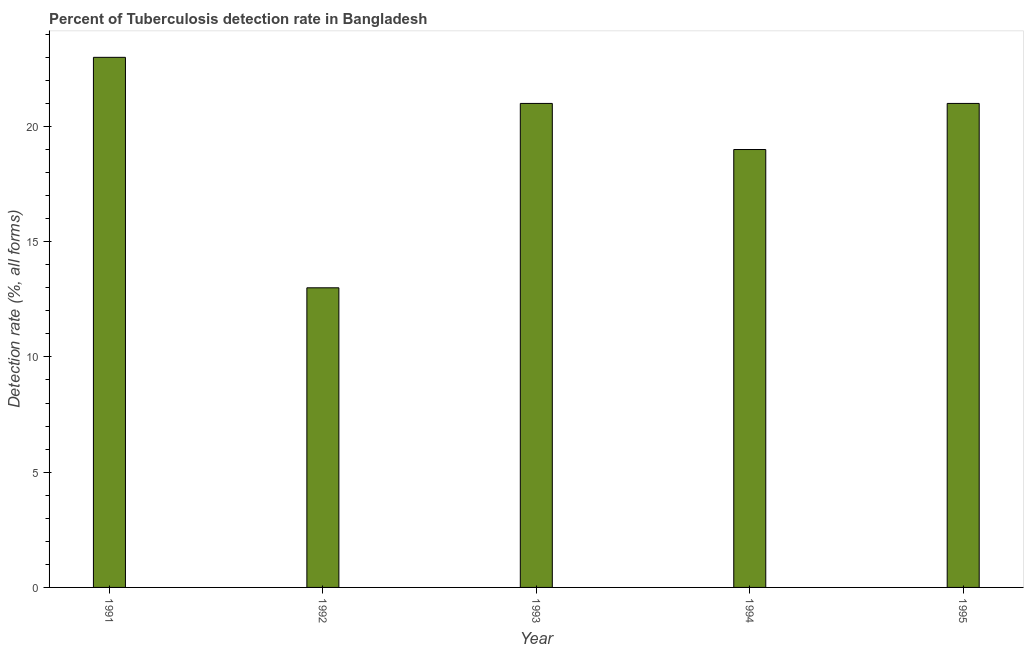Does the graph contain grids?
Make the answer very short. No. What is the title of the graph?
Your response must be concise. Percent of Tuberculosis detection rate in Bangladesh. What is the label or title of the Y-axis?
Your answer should be compact. Detection rate (%, all forms). What is the sum of the detection rate of tuberculosis?
Give a very brief answer. 97. What is the difference between the detection rate of tuberculosis in 1992 and 1995?
Your answer should be very brief. -8. What is the average detection rate of tuberculosis per year?
Ensure brevity in your answer.  19. In how many years, is the detection rate of tuberculosis greater than 9 %?
Your response must be concise. 5. Do a majority of the years between 1991 and 1995 (inclusive) have detection rate of tuberculosis greater than 22 %?
Keep it short and to the point. No. What is the ratio of the detection rate of tuberculosis in 1993 to that in 1994?
Offer a terse response. 1.1. Is the difference between the detection rate of tuberculosis in 1993 and 1995 greater than the difference between any two years?
Provide a short and direct response. No. What is the difference between the highest and the second highest detection rate of tuberculosis?
Give a very brief answer. 2. Is the sum of the detection rate of tuberculosis in 1991 and 1994 greater than the maximum detection rate of tuberculosis across all years?
Offer a very short reply. Yes. What is the difference between the highest and the lowest detection rate of tuberculosis?
Your answer should be very brief. 10. Are all the bars in the graph horizontal?
Provide a short and direct response. No. Are the values on the major ticks of Y-axis written in scientific E-notation?
Offer a very short reply. No. What is the Detection rate (%, all forms) of 1992?
Offer a very short reply. 13. What is the Detection rate (%, all forms) in 1994?
Provide a short and direct response. 19. What is the difference between the Detection rate (%, all forms) in 1991 and 1992?
Your response must be concise. 10. What is the difference between the Detection rate (%, all forms) in 1991 and 1993?
Your answer should be very brief. 2. What is the difference between the Detection rate (%, all forms) in 1991 and 1995?
Your response must be concise. 2. What is the difference between the Detection rate (%, all forms) in 1992 and 1993?
Provide a short and direct response. -8. What is the difference between the Detection rate (%, all forms) in 1992 and 1995?
Your answer should be compact. -8. What is the ratio of the Detection rate (%, all forms) in 1991 to that in 1992?
Make the answer very short. 1.77. What is the ratio of the Detection rate (%, all forms) in 1991 to that in 1993?
Make the answer very short. 1.09. What is the ratio of the Detection rate (%, all forms) in 1991 to that in 1994?
Make the answer very short. 1.21. What is the ratio of the Detection rate (%, all forms) in 1991 to that in 1995?
Offer a very short reply. 1.09. What is the ratio of the Detection rate (%, all forms) in 1992 to that in 1993?
Your response must be concise. 0.62. What is the ratio of the Detection rate (%, all forms) in 1992 to that in 1994?
Offer a very short reply. 0.68. What is the ratio of the Detection rate (%, all forms) in 1992 to that in 1995?
Ensure brevity in your answer.  0.62. What is the ratio of the Detection rate (%, all forms) in 1993 to that in 1994?
Offer a very short reply. 1.1. What is the ratio of the Detection rate (%, all forms) in 1994 to that in 1995?
Offer a terse response. 0.91. 